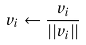Convert formula to latex. <formula><loc_0><loc_0><loc_500><loc_500>v _ { i } \leftarrow \frac { v _ { i } } { | | v _ { i } | | }</formula> 